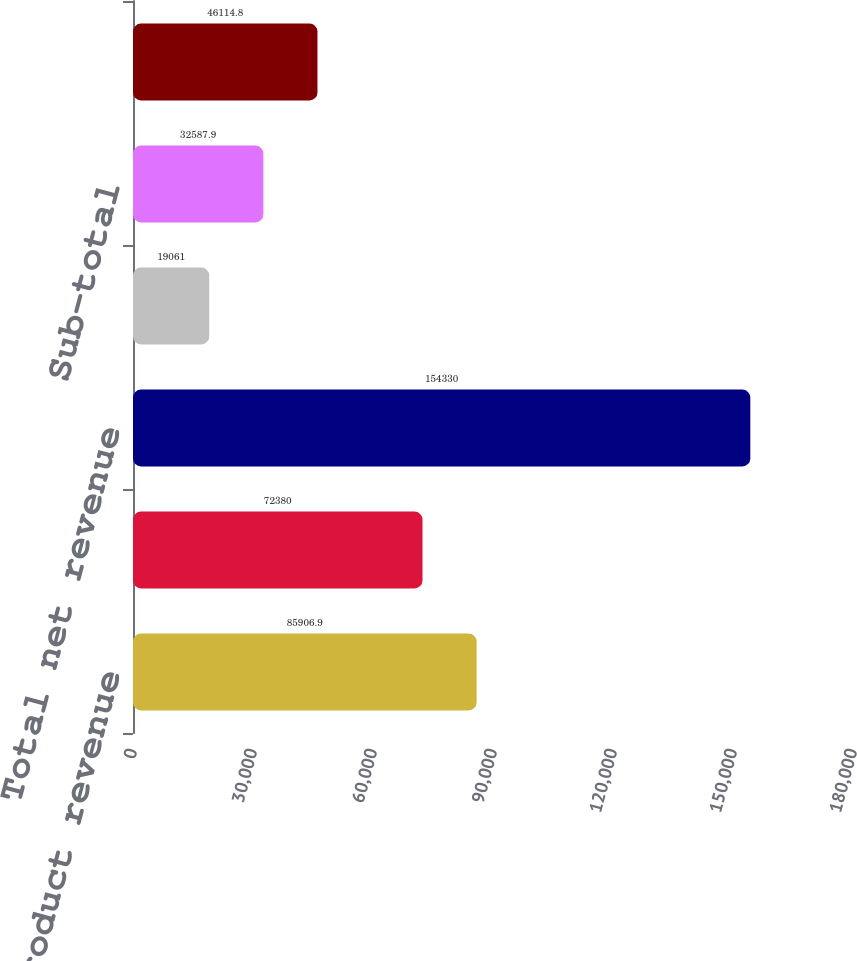<chart> <loc_0><loc_0><loc_500><loc_500><bar_chart><fcel>Product revenue<fcel>Service revenue<fcel>Total net revenue<fcel>Segment operating income<fcel>Sub-total<fcel>Income (loss) from continuing<nl><fcel>85906.9<fcel>72380<fcel>154330<fcel>19061<fcel>32587.9<fcel>46114.8<nl></chart> 